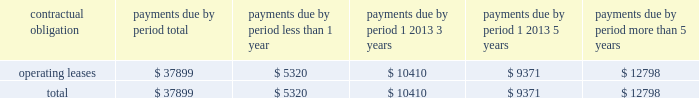As of december 31 , 2006 , we also leased an office and laboratory facility in connecticut , additional office , distribution and storage facilities in san diego , and four foreign facilities located in japan , singapore , china and the netherlands under non-cancelable operating leases that expire at various times through july 2011 .
These leases contain renewal options ranging from one to five years .
As of december 31 , 2006 , our contractual obligations were ( in thousands ) : contractual obligation total less than 1 year 1 2013 3 years 1 2013 5 years more than 5 years .
The above table does not include orders for goods and services entered into in the normal course of business that are not enforceable or legally binding .
Item 7a .
Quantitative and qualitative disclosures about market risk .
Interest rate sensitivity our exposure to market risk for changes in interest rates relates primarily to our investment portfolio .
The fair market value of fixed rate securities may be adversely impacted by fluctuations in interest rates while income earned on floating rate securities may decline as a result of decreases in interest rates .
Under our current policies , we do not use interest rate derivative instruments to manage exposure to interest rate changes .
We attempt to ensure the safety and preservation of our invested principal funds by limiting default risk , market risk and reinvestment risk .
We mitigate default risk by investing in investment grade securities .
We have historically maintained a relatively short average maturity for our investment portfolio , and we believe a hypothetical 100 basis point adverse move in interest rates along the entire interest rate yield curve would not materially affect the fair value of our interest sensitive financial instruments .
Foreign currency exchange risk although most of our revenue is realized in u.s .
Dollars , some portions of our revenue are realized in foreign currencies .
As a result , our financial results could be affected by factors such as changes in foreign currency exchange rates or weak economic conditions in foreign markets .
The functional currencies of our subsidiaries are their respective local currencies .
Accordingly , the accounts of these operations are translated from the local currency to the u.s .
Dollar using the current exchange rate in effect at the balance sheet date for the balance sheet accounts , and using the average exchange rate during the period for revenue and expense accounts .
The effects of translation are recorded in accumulated other comprehensive income as a separate component of stockholders 2019 equity. .
What is the percent of the operating leases that are due in 1 2013 3 years to the total leases .? 
Computations: (10410 / 37899)
Answer: 0.27468. 